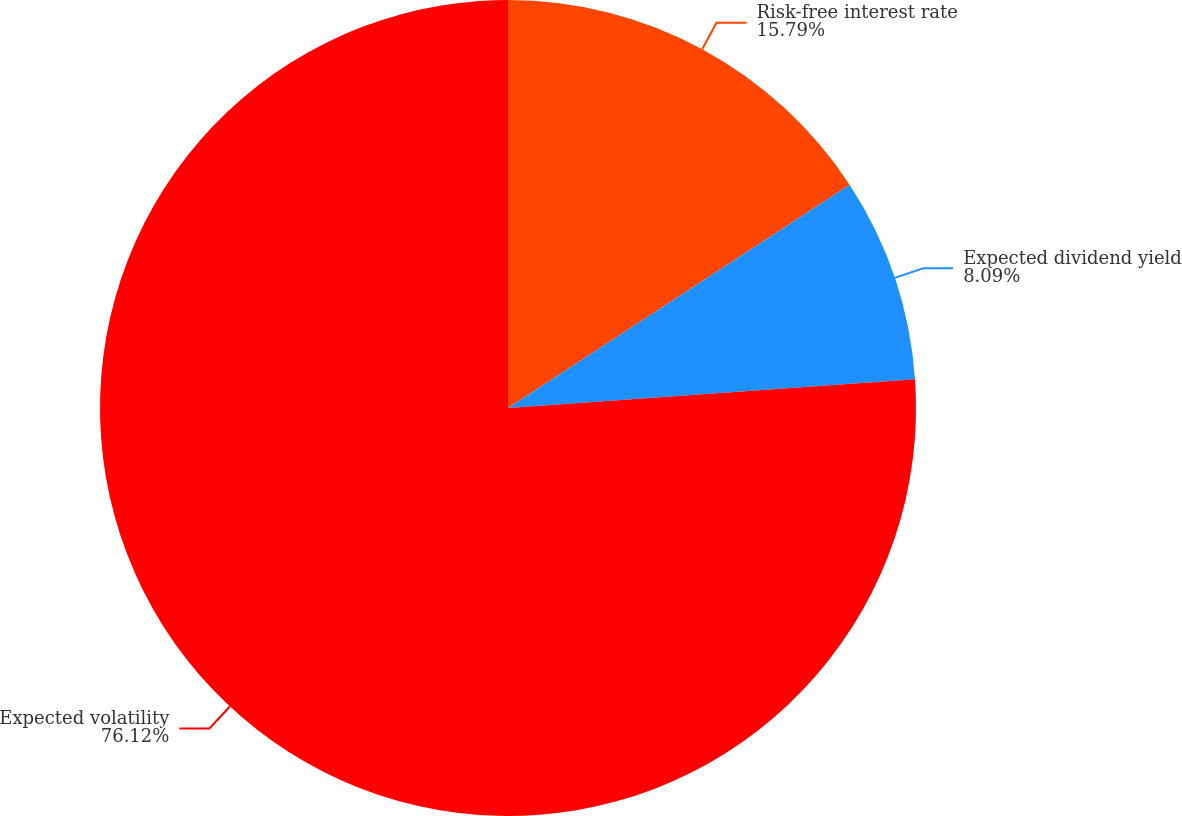Convert chart to OTSL. <chart><loc_0><loc_0><loc_500><loc_500><pie_chart><fcel>Risk-free interest rate<fcel>Expected dividend yield<fcel>Expected volatility<nl><fcel>15.79%<fcel>8.09%<fcel>76.12%<nl></chart> 